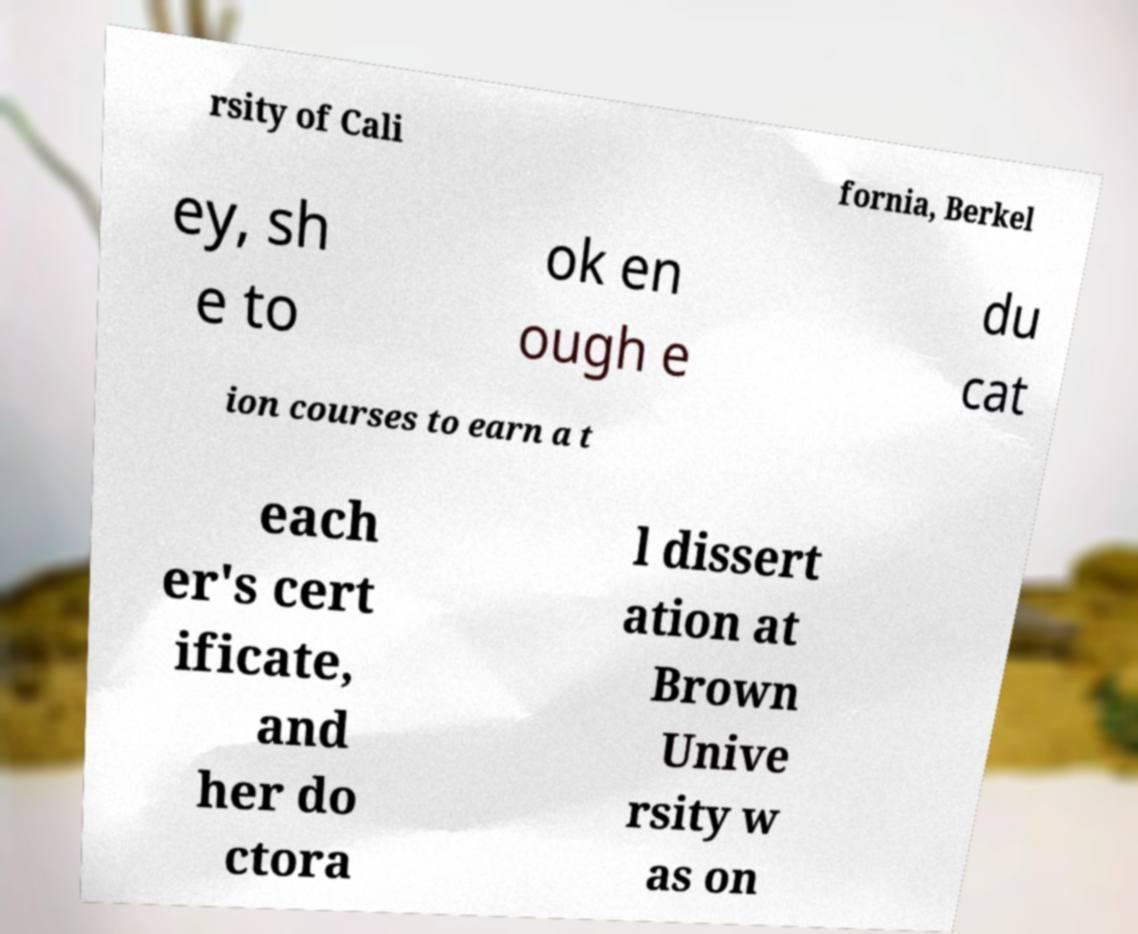I need the written content from this picture converted into text. Can you do that? rsity of Cali fornia, Berkel ey, sh e to ok en ough e du cat ion courses to earn a t each er's cert ificate, and her do ctora l dissert ation at Brown Unive rsity w as on 